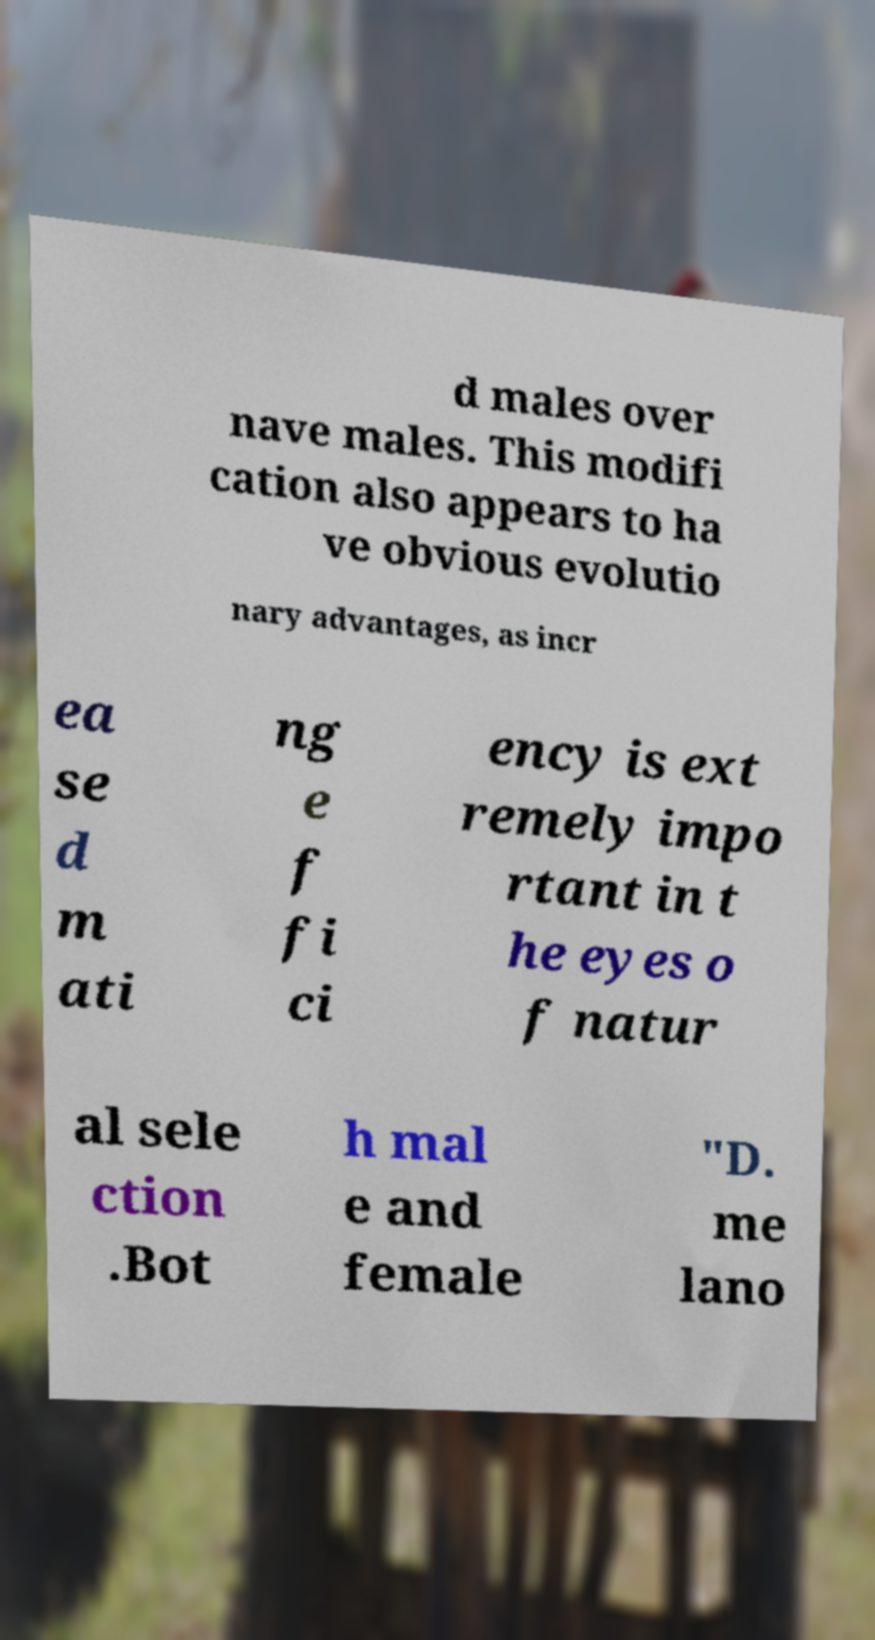What messages or text are displayed in this image? I need them in a readable, typed format. d males over nave males. This modifi cation also appears to ha ve obvious evolutio nary advantages, as incr ea se d m ati ng e f fi ci ency is ext remely impo rtant in t he eyes o f natur al sele ction .Bot h mal e and female "D. me lano 